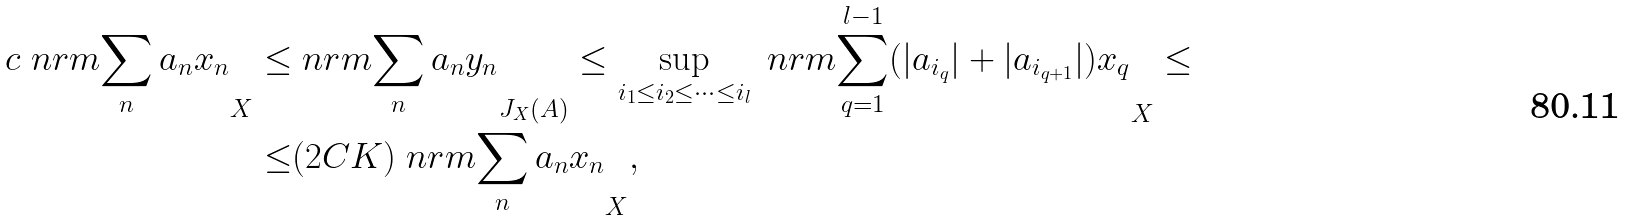Convert formula to latex. <formula><loc_0><loc_0><loc_500><loc_500>c \ n r m { \sum _ { n } a _ { n } x _ { n } } _ { X } \leq & \ n r m { \sum _ { n } a _ { n } y _ { n } } _ { J _ { X } ( A ) } \leq \sup _ { i _ { 1 } \leq i _ { 2 } \leq \dots \leq i _ { l } } \ n r m { \sum _ { q = 1 } ^ { l - 1 } ( | a _ { i _ { q } } | + | a _ { i _ { q + 1 } } | ) x _ { q } } _ { X } \leq \\ \leq & ( 2 C K ) \ n r m { \sum _ { n } a _ { n } x _ { n } } _ { X } ,</formula> 